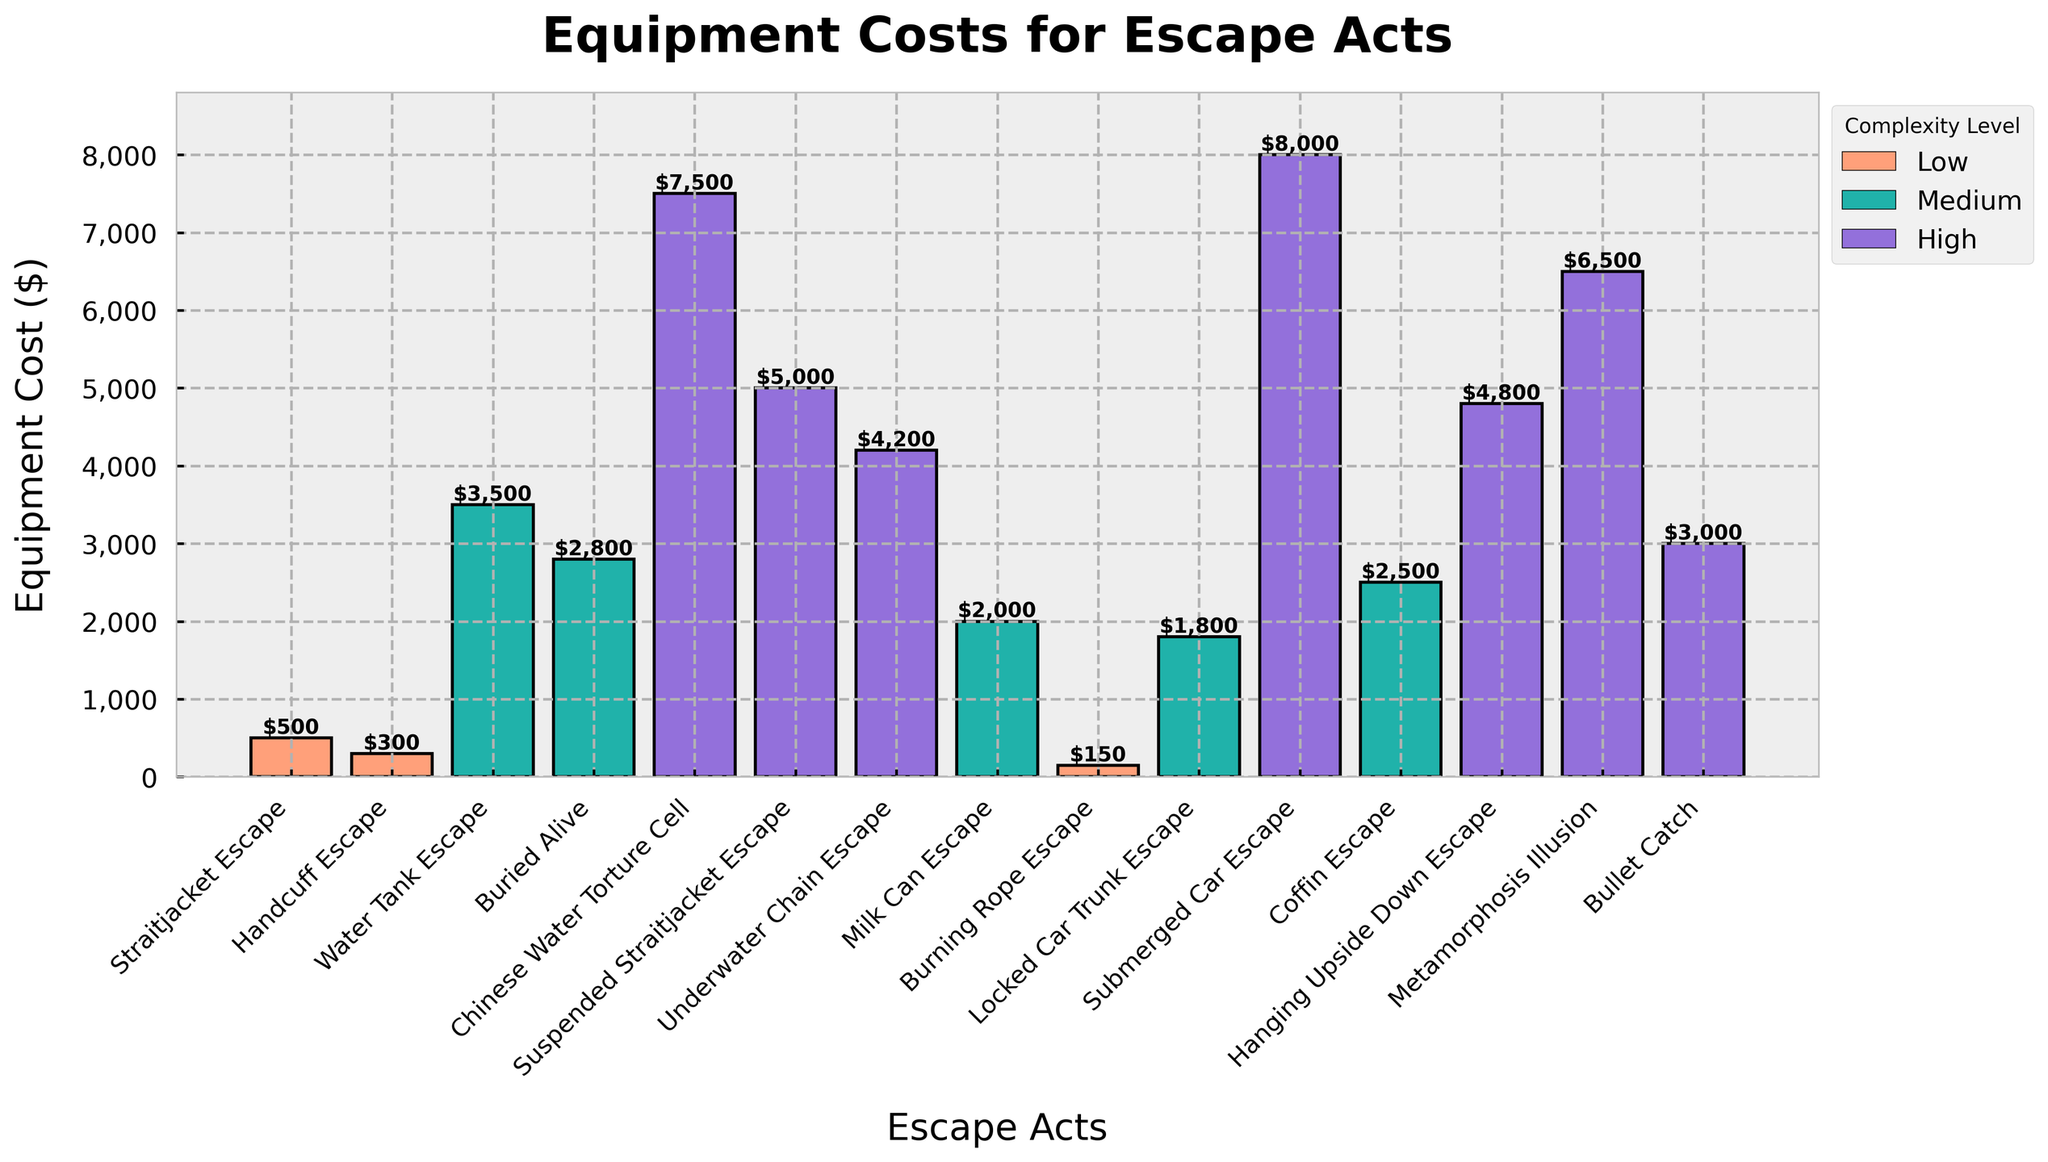what is the total cost of the Low complexity level acts? Add the equipment costs of all Low complexity level acts: Straitjacket Escape ($500) + Handcuff Escape ($300) + Burning Rope Escape ($150) = $950.
Answer: $950 Which act has the highest equipment cost? The act with the highest bar on the chart represents the highest equipment cost. The Submerged Car Escape has the tallest bar, indicating the highest cost of $8000.
Answer: Submerged Car Escape Compare the equipment costs of the Medium complexity level acts and identify which one is the least expensive? Compare the heights of the bars for the Medium complexity level acts (Water Tank Escape, Buried Alive, Milk Can Escape, Locked Car Trunk Escape, and Coffin Escape). Milk Can Escape has the lowest bar, indicating it is the least expensive at $2,000.
Answer: Milk Can Escape What is the total cost of the High complexity level acts? Add the equipment costs of all High complexity level acts: Chinese Water Torture Cell ($7500) + Suspended Straitjacket Escape ($5000) + Underwater Chain Escape ($4200) + Submerged Car Escape ($8000) + Hanging Upside Down Escape ($4800) + Metamorphosis Illusion ($6500) + Bullet Catch ($3000) = $39000.
Answer: $39,000 What's the average equipment cost for the Medium complexity level acts? Sum the costs of Medium complexity level acts: Water Tank Escape ($3500) + Buried Alive ($2800) + Milk Can Escape ($2000) + Locked Car Trunk Escape ($1800) + Coffin Escape ($2500) = $12600. There are 5 Medium complexity level acts, so the average is $12600/5 = $2520.
Answer: $2520 Which act has a higher cost, Submerged Car Escape or Chinese Water Torture Cell? Compare the heights of the bars for Submerged Car Escape ($8000) and Chinese Water Torture Cell ($7500). The bar for Submerged Car Escape is taller, indicating a higher cost.
Answer: Submerged Car Escape How much more does the Hanging Upside Down Escape cost compared to the Bullet Catch? Subtract the cost of the Bullet Catch ($3000) from the cost of the Hanging Upside Down Escape ($4800): $4800 - $3000 = $1800.
Answer: $1800 Which act has the lowest cost across all complexity levels? The Burning Rope Escape has the shortest bar on the chart representing $150, indicating it has the lowest cost.
Answer: Burning Rope Escape What is the median cost of the High complexity level acts? List the costs of the High complexity level acts in ascending order: Bullet Catch ($3000), Underwater Chain Escape ($4200), Hanging Upside Down Escape ($4800), Suspended Straitjacket Escape ($5000), Chinese Water Torture Cell ($7500), Metamorphosis Illusion ($6500), Submerged Car Escape ($8000). The median cost is the middle value, which is $5000 (Suspended Straitjacket Escape).
Answer: $5000 